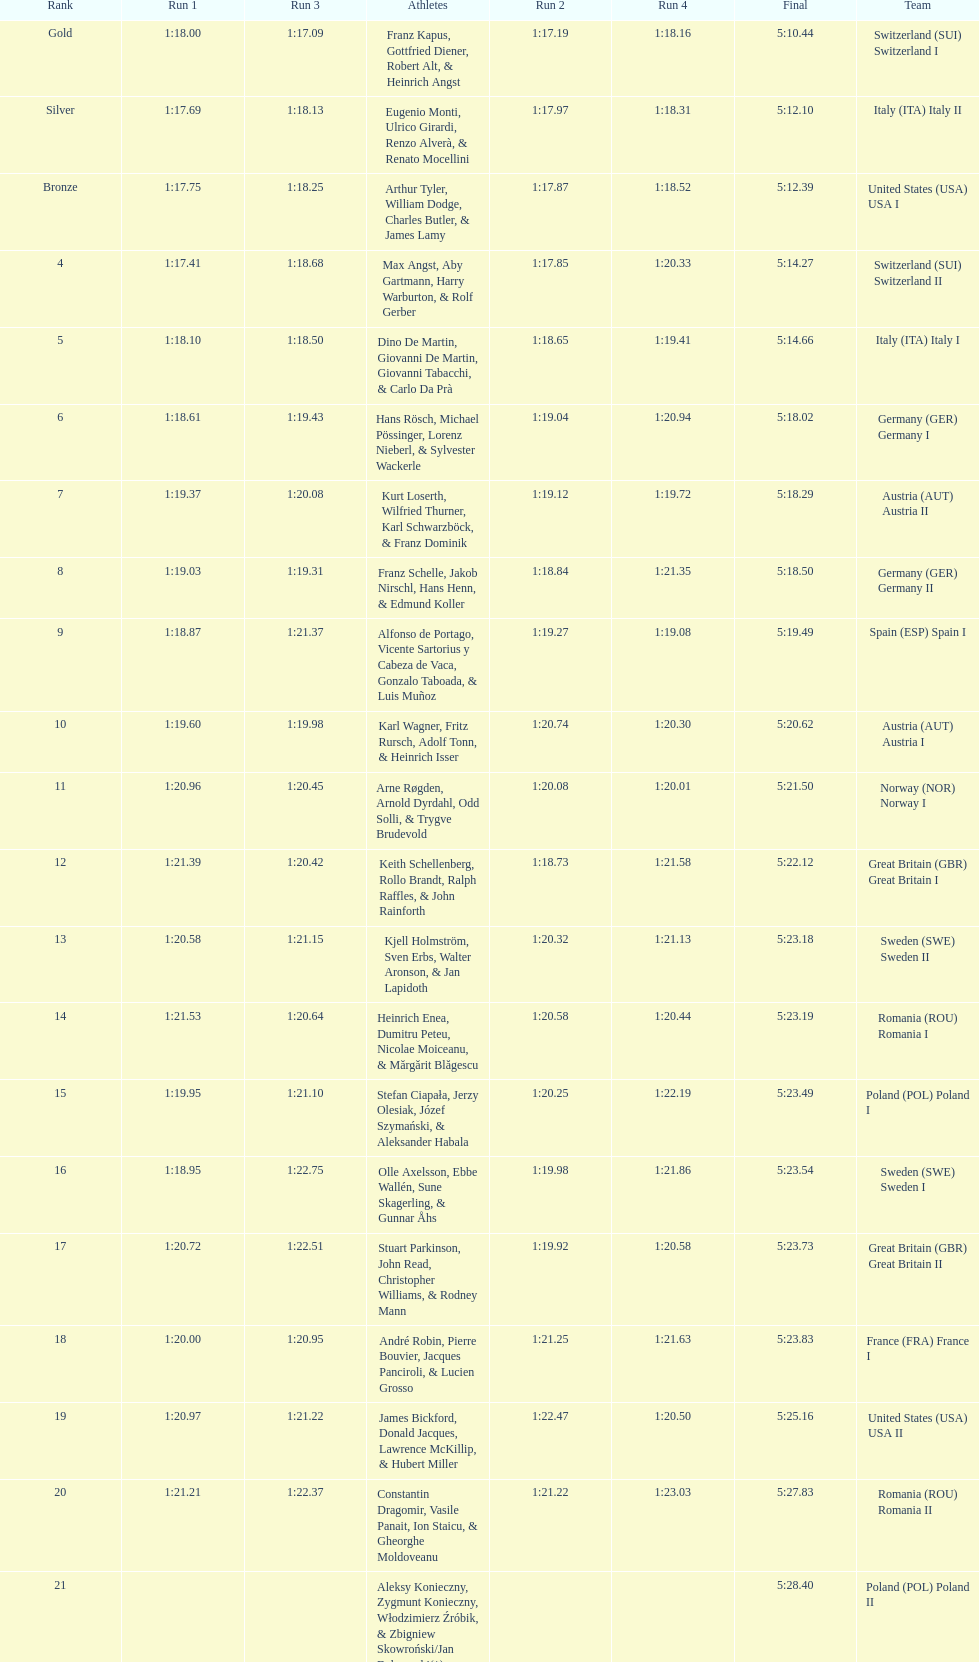Which team had the most time? Poland. 